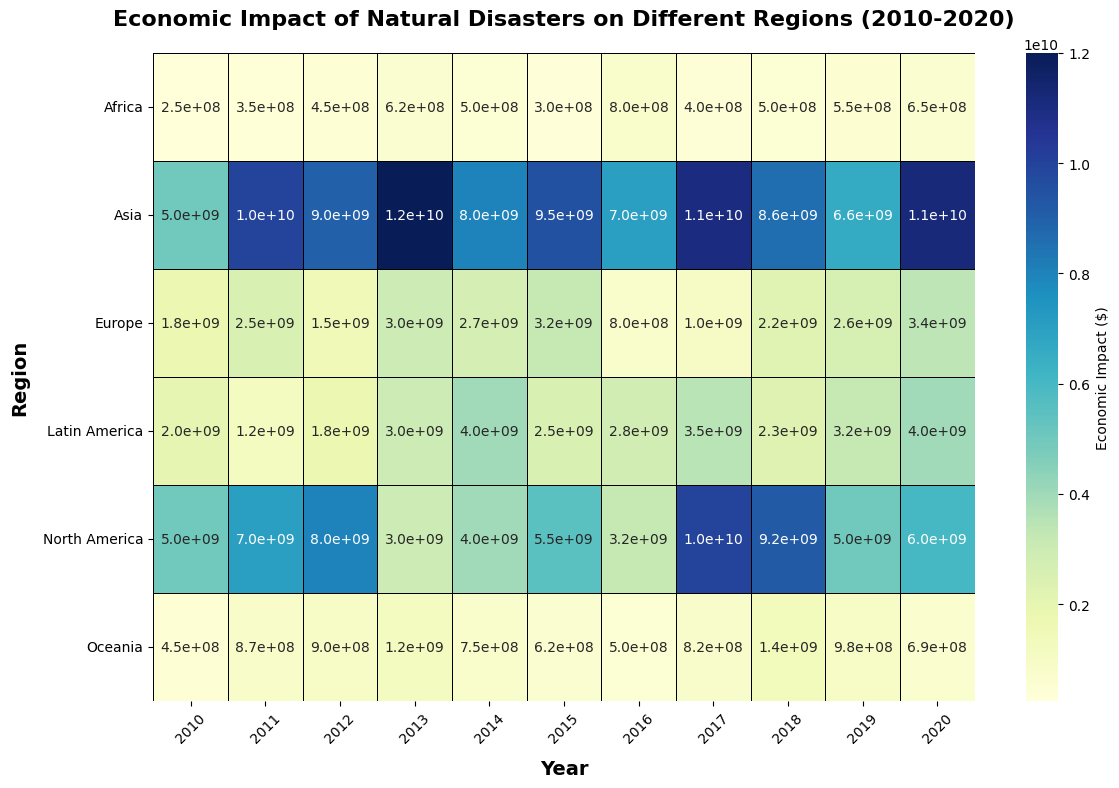What region experienced the highest economic impact due to natural disasters in 2017? Scan the 2017 column for the highest value in the heatmap. The highest economic impact in 2017 is 1.1e+10 in Asia.
Answer: Asia Which year had the lowest total economic impact in Europe? Add up the values for each year in Europe and compare. The year 2016 has the lowest total with 8.0e+08.
Answer: 2016 What is the average economic impact of disasters in North America over the decade? Sum up the values for each year in North America and divide by the number of years. The sum is 6.9e+10 and the number of years is 11, giving an average of approximately 6.27e+09.
Answer: 6.27e+09 Is the economic impact caused by natural disasters in Asia higher in 2015 or 2020? Compare the values for Asia in 2015 and 2020. The value in 2020 (1.12e+10) is higher than in 2015 (9.5e+09).
Answer: 2020 Which region had the smallest economic impact due to natural disasters in 2010? Scan the 2010 column for the lowest value in the heatmap. The smallest impact in 2010 is 2.5e+08 in Africa.
Answer: Africa What was the total economic impact of hurricanes in North America over the decade? Identify the values corresponding to hurricanes in North America and sum them up. The sum is (5e+09 + 7e+09 + 8e+09 + 5.5e+09 + 1e+10 + 9.2e+09 + 6e+09) = 5.32e+10.
Answer: 5.32e+10 Which region had the most consistent economic impact across all years, and what does this pattern look like visually? Visually scan the row for each region to see the consistency in color shades across columns (years). Europe shows the most consistent pattern with similar shades throughout.
Answer: Europe How did the economic impact of earthquakes in Latin America change from 2010 to 2020? Compare the values for earthquakes in 2010 and 2020 in Latin America. In 2010 the impact was 2e+09, and in 2020 it increased to 4e+09.
Answer: The economic impact doubled What is the difference in economic impact between the highest and lowest years in Asia? Identify the highest (2013: 1.2e+10) and lowest values (2016: 7e+09) in Asia and compute the difference: 1.2e+10 - 7e+09 = 5e+09.
Answer: 5e+09 In which year did Oceania experience the highest economic impact from natural disasters? Scan the Oceania row to find the highest value, which is in 2018 with a value of 1.35e+09.
Answer: 2018 